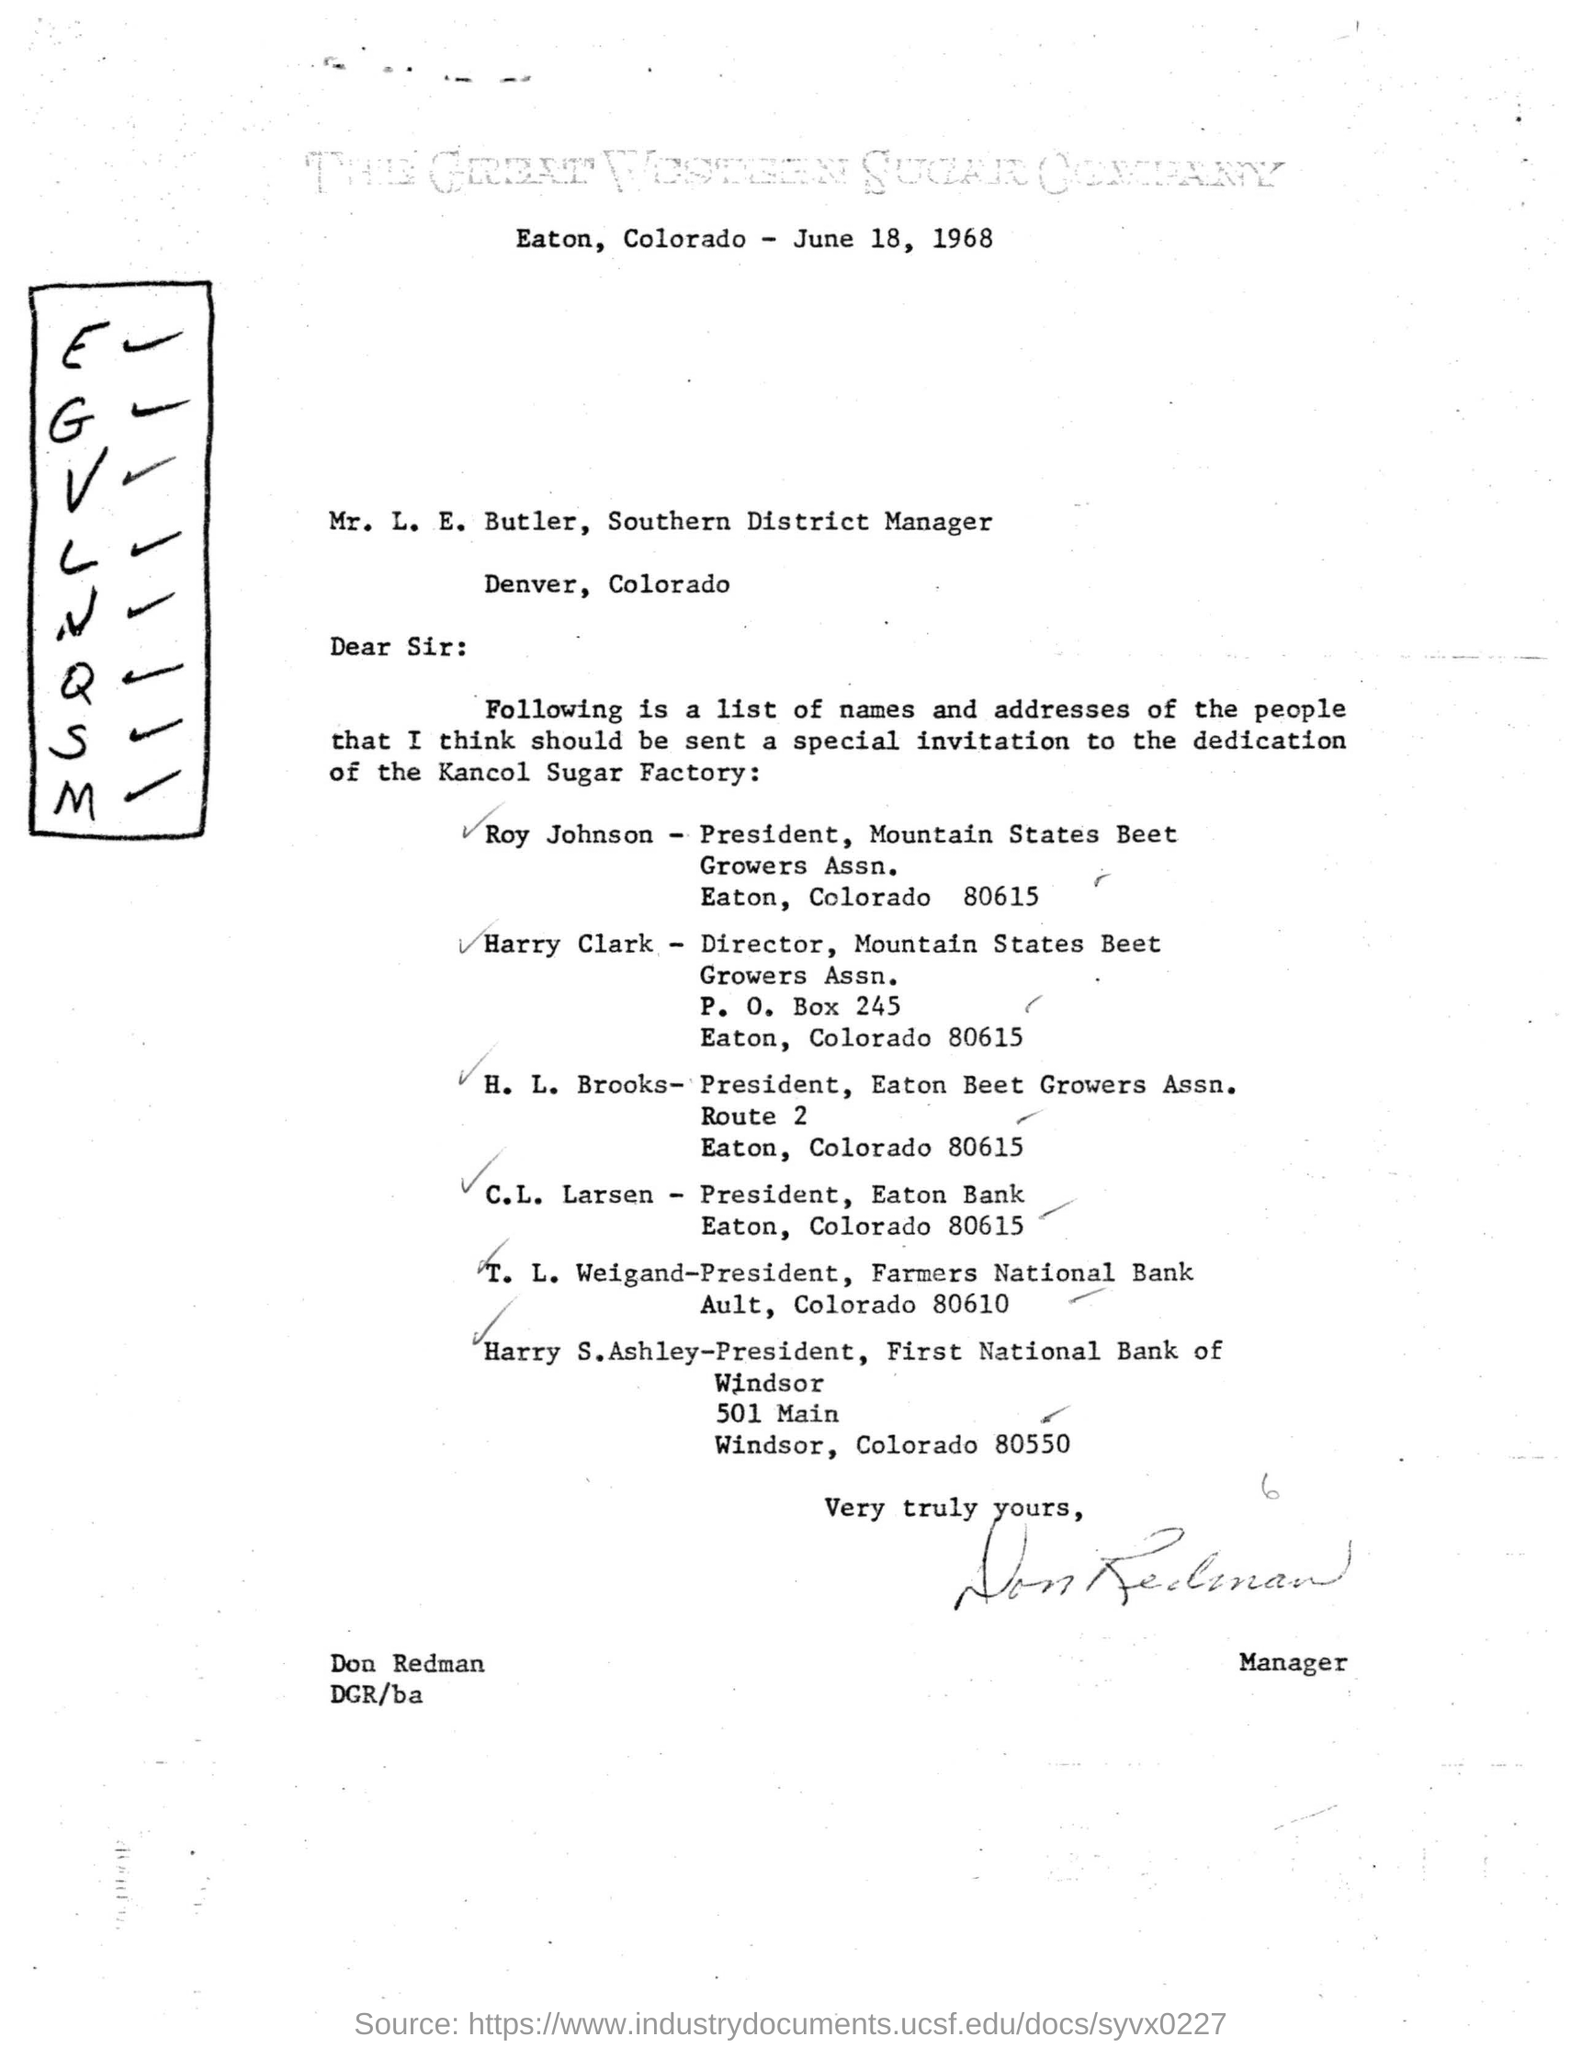Indicate a few pertinent items in this graphic. The letter, dated June 18, 1968, states... The President of the Mountain States Beet Growers Association is Roy Johnson, who resides in Eaton, Colorado. I, Harry Clark, am the proud Director of the Mountain States Beet Growers Association. 